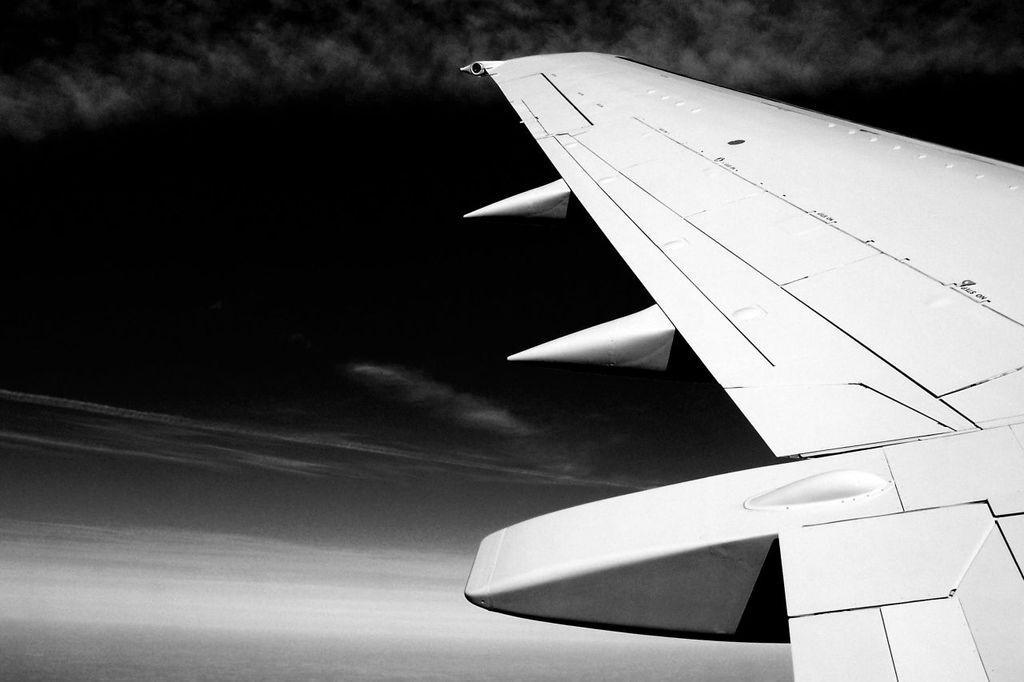Please provide a concise description of this image. In this black and white picture there is an airplane flying in the air. Background there is sky, having clouds. 